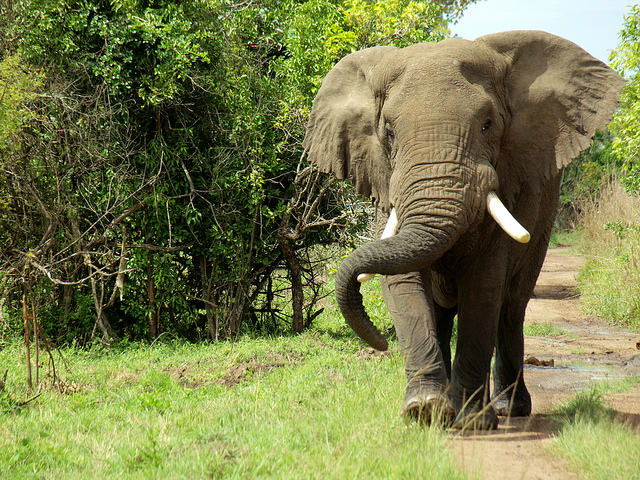<image>How does the elephant feel? It is unanswerable to determine how the elephant feels. How does the elephant feel? I don't know how the elephant feels. It is ambiguous to determine its emotions. 